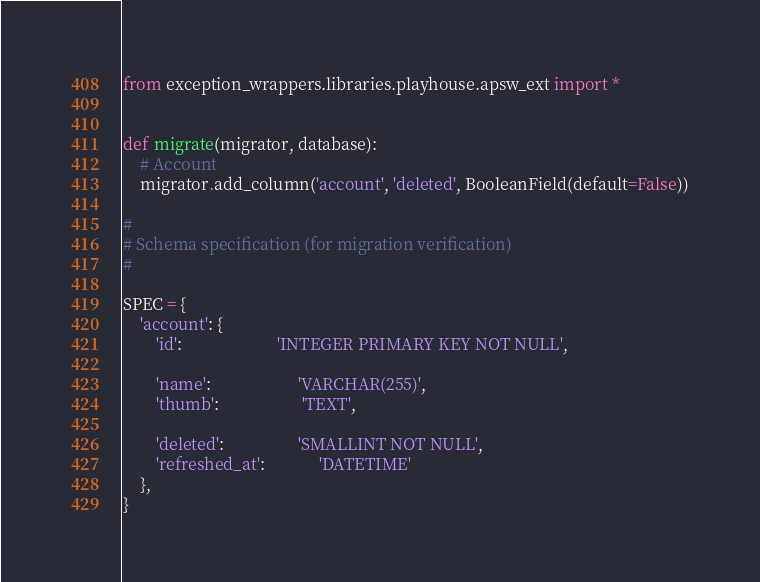<code> <loc_0><loc_0><loc_500><loc_500><_Python_>from exception_wrappers.libraries.playhouse.apsw_ext import *


def migrate(migrator, database):
    # Account
    migrator.add_column('account', 'deleted', BooleanField(default=False))

#
# Schema specification (for migration verification)
#

SPEC = {
    'account': {
        'id':                       'INTEGER PRIMARY KEY NOT NULL',

        'name':                     'VARCHAR(255)',
        'thumb':                    'TEXT',

        'deleted':                  'SMALLINT NOT NULL',
        'refreshed_at':             'DATETIME'
    },
}
</code> 